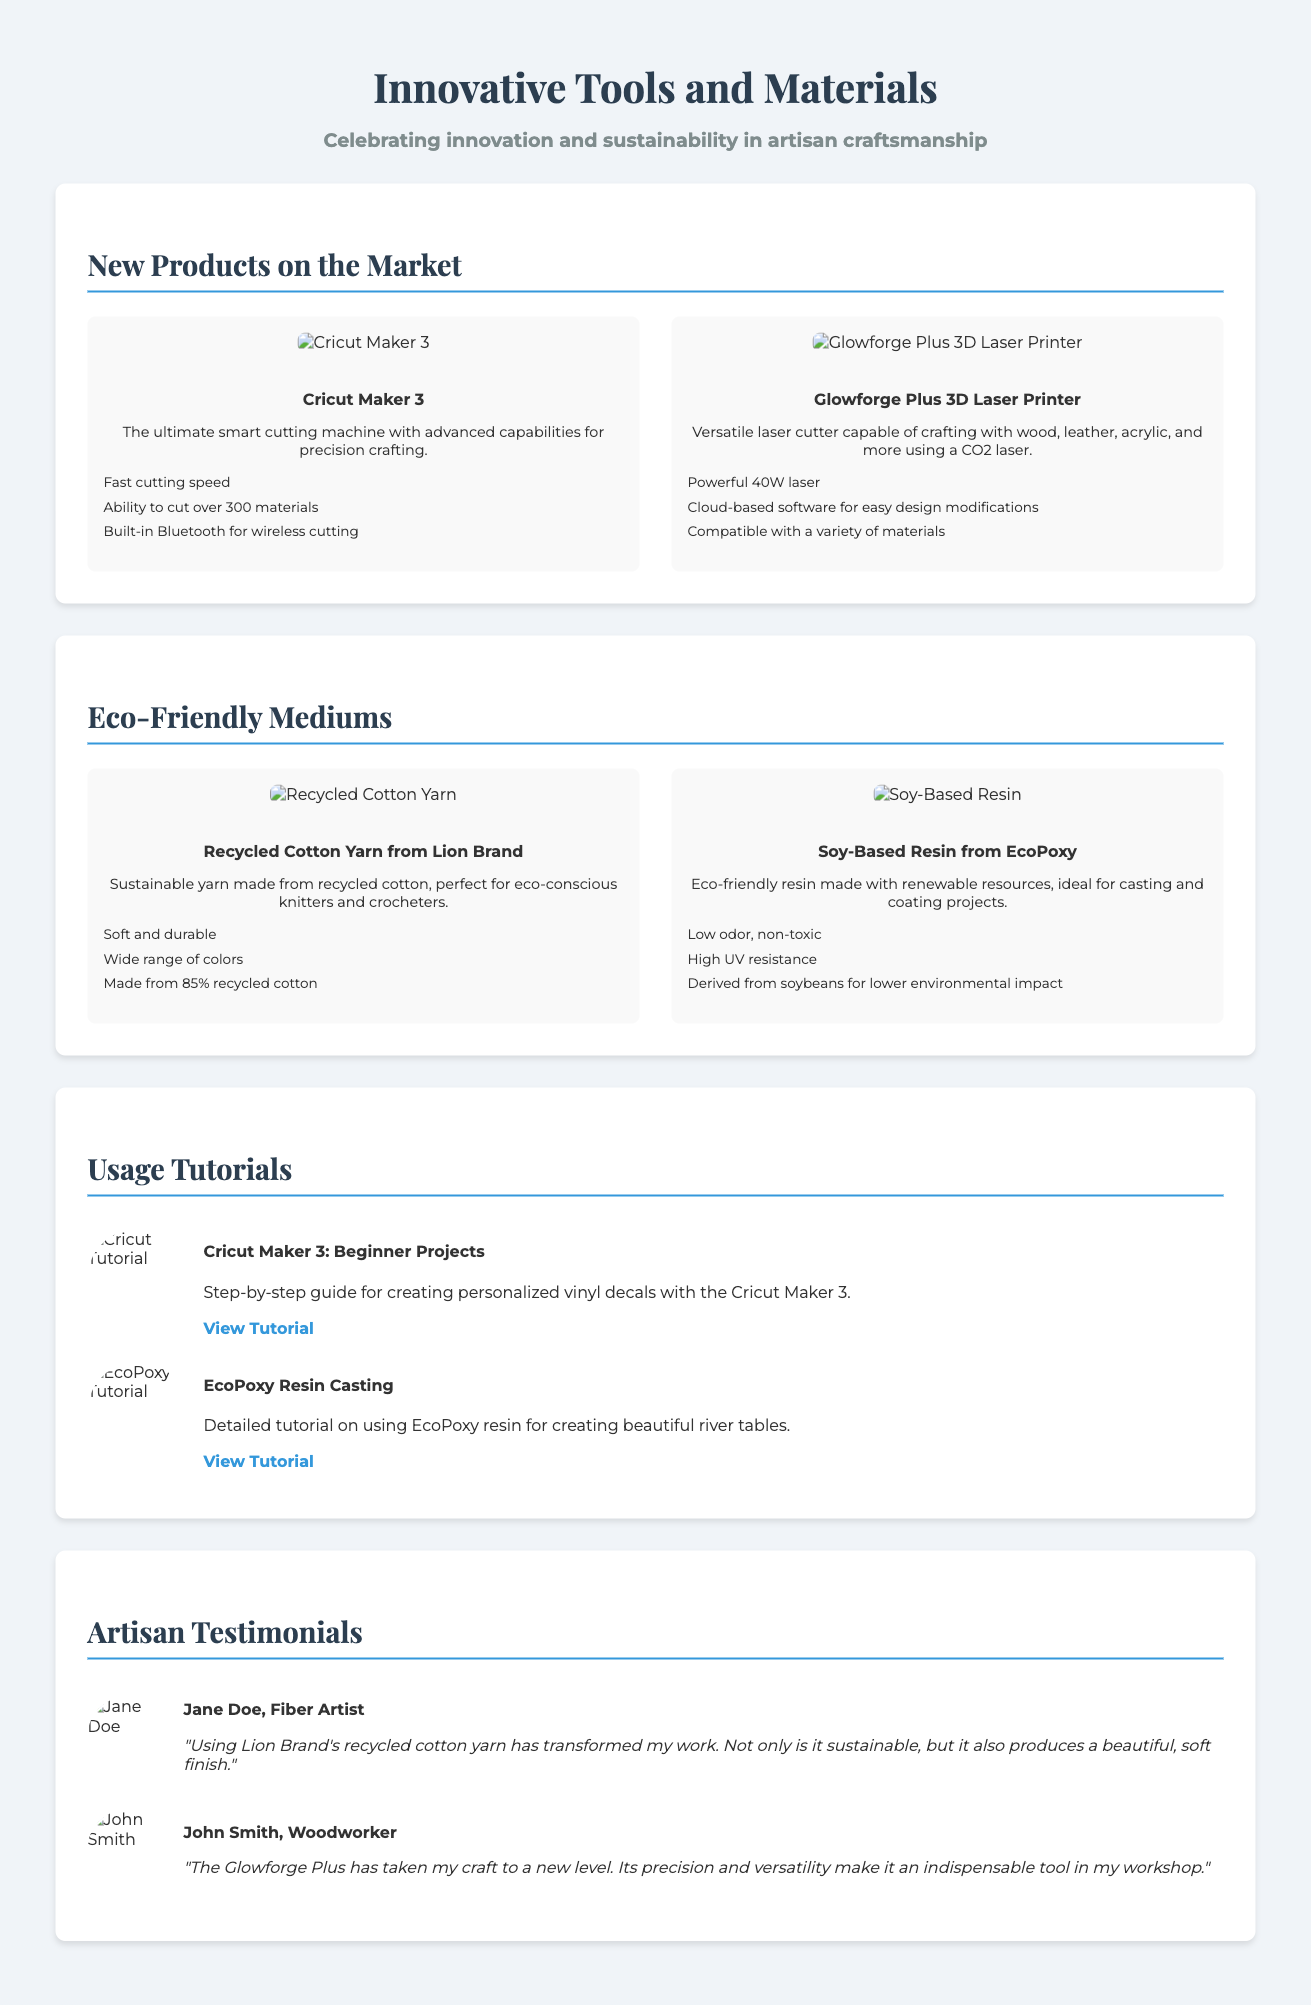what is the name of the ultimate smart cutting machine? The document mentions that the ultimate smart cutting machine is called the Cricut Maker 3.
Answer: Cricut Maker 3 what material can the Glowforge Plus cut? The document states that the Glowforge Plus can craft with wood, leather, acrylic, and more.
Answer: wood, leather, acrylic what percentage of recycled cotton is in the Recycled Cotton Yarn? The document specifies that the Recycled Cotton Yarn is made from 85% recycled cotton.
Answer: 85% how many materials can the Cricut Maker 3 cut? The document indicates that the Cricut Maker 3 can cut over 300 materials.
Answer: over 300 who is quoted in the testimonial section about the Glowforge Plus? The document features a testimonial from John Smith, who is a woodworker.
Answer: John Smith what is the focus of the "Eco-Friendly Mediums" section? The document emphasizes sustainable materials used in crafting, including yarn and resin.
Answer: sustainable materials how does the EcoPoxy resin rank in terms of odor? The document notes that the EcoPoxy resin is low odor and non-toxic.
Answer: low odor which tutorial focuses on creating river tables? The document mentions a tutorial specifically about EcoPoxy resin for creating beautiful river tables.
Answer: EcoPoxy Resin Casting 